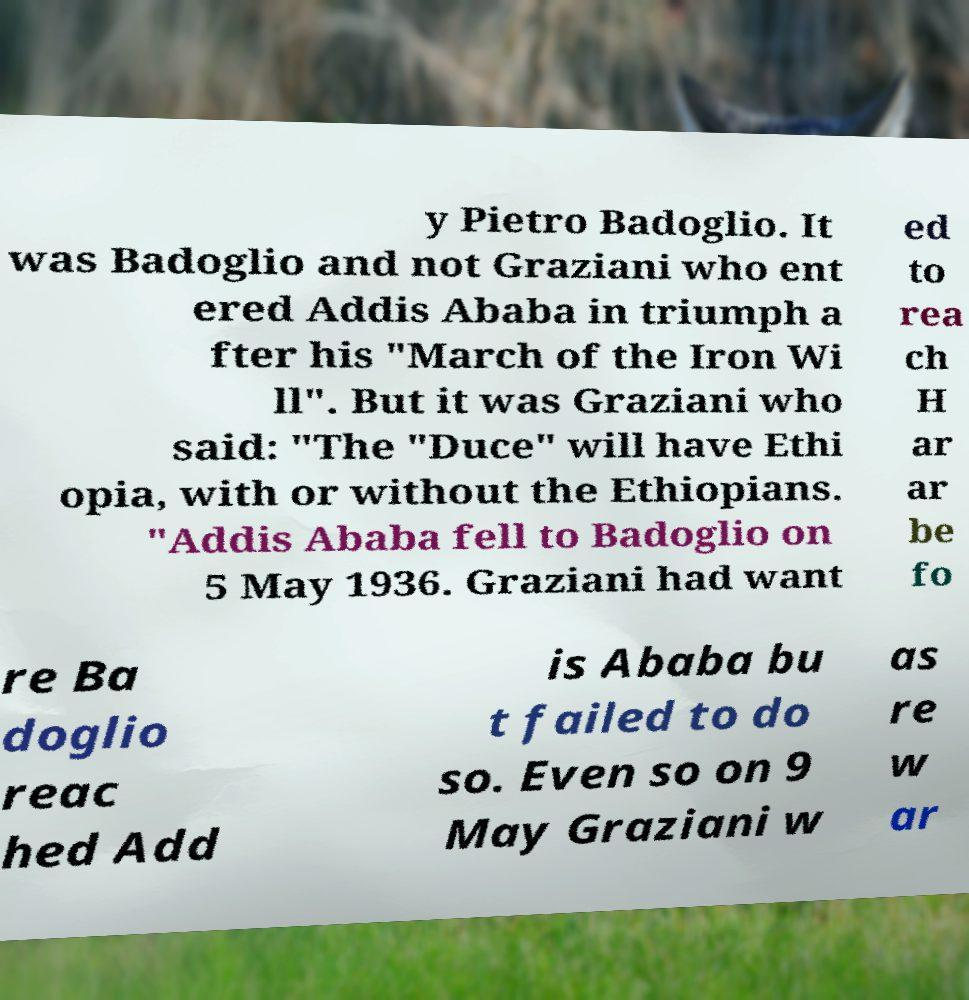Please read and relay the text visible in this image. What does it say? y Pietro Badoglio. It was Badoglio and not Graziani who ent ered Addis Ababa in triumph a fter his "March of the Iron Wi ll". But it was Graziani who said: "The "Duce" will have Ethi opia, with or without the Ethiopians. "Addis Ababa fell to Badoglio on 5 May 1936. Graziani had want ed to rea ch H ar ar be fo re Ba doglio reac hed Add is Ababa bu t failed to do so. Even so on 9 May Graziani w as re w ar 